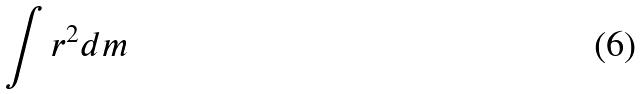Convert formula to latex. <formula><loc_0><loc_0><loc_500><loc_500>\int r ^ { 2 } d m</formula> 